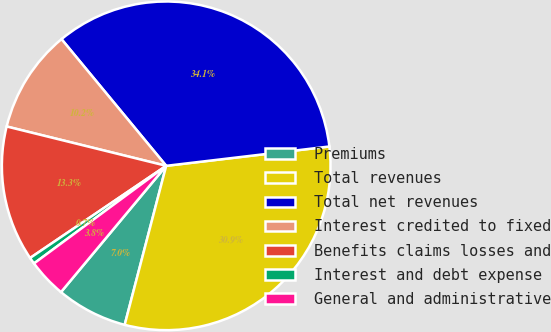<chart> <loc_0><loc_0><loc_500><loc_500><pie_chart><fcel>Premiums<fcel>Total revenues<fcel>Total net revenues<fcel>Interest credited to fixed<fcel>Benefits claims losses and<fcel>Interest and debt expense<fcel>General and administrative<nl><fcel>6.99%<fcel>30.94%<fcel>34.11%<fcel>10.16%<fcel>13.32%<fcel>0.65%<fcel>3.82%<nl></chart> 